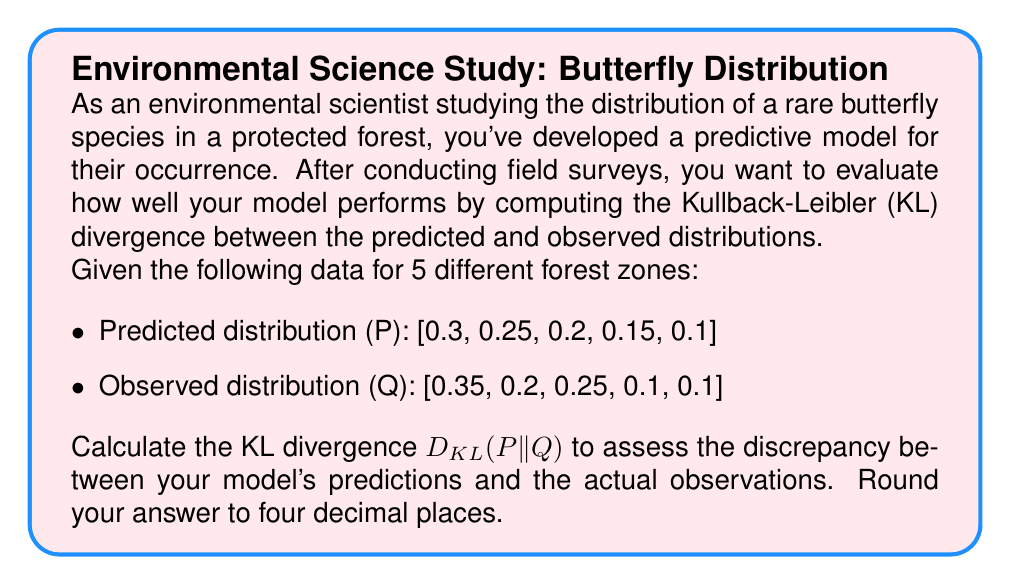Can you answer this question? To solve this problem, we'll follow these steps:

1) The Kullback-Leibler divergence from P to Q is defined as:

   $$D_{KL}(P||Q) = \sum_{i} P(i) \log \left(\frac{P(i)}{Q(i)}\right)$$

2) Let's calculate each term of the sum:

   For i = 1: $0.3 \log(\frac{0.3}{0.35}) = 0.3 \log(0.8571) = -0.0460$
   For i = 2: $0.25 \log(\frac{0.25}{0.2}) = 0.25 \log(1.25) = 0.0558$
   For i = 3: $0.2 \log(\frac{0.2}{0.25}) = 0.2 \log(0.8) = -0.0446$
   For i = 4: $0.15 \log(\frac{0.15}{0.1}) = 0.15 \log(1.5) = 0.0608$
   For i = 5: $0.1 \log(\frac{0.1}{0.1}) = 0.1 \log(1) = 0$

3) Sum all these terms:

   $D_{KL}(P||Q) = (-0.0460) + 0.0558 + (-0.0446) + 0.0608 + 0 = 0.0260$

4) Rounding to four decimal places:

   $D_{KL}(P||Q) \approx 0.0260$

This value indicates a relatively small divergence between the predicted and observed distributions, suggesting that your model performs reasonably well in predicting the butterfly species distribution across the forest zones.
Answer: 0.0260 